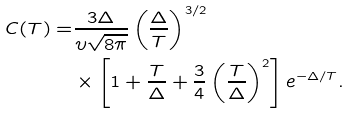<formula> <loc_0><loc_0><loc_500><loc_500>C ( T ) = & \frac { 3 \Delta } { \upsilon \sqrt { 8 \pi } } \left ( \frac { \Delta } { T } \right ) ^ { 3 / 2 } \\ & \times \left [ 1 + \frac { T } { \Delta } + \frac { 3 } { 4 } \left ( \frac { T } { \Delta } \right ) ^ { 2 } \right ] e ^ { - \Delta / T } .</formula> 